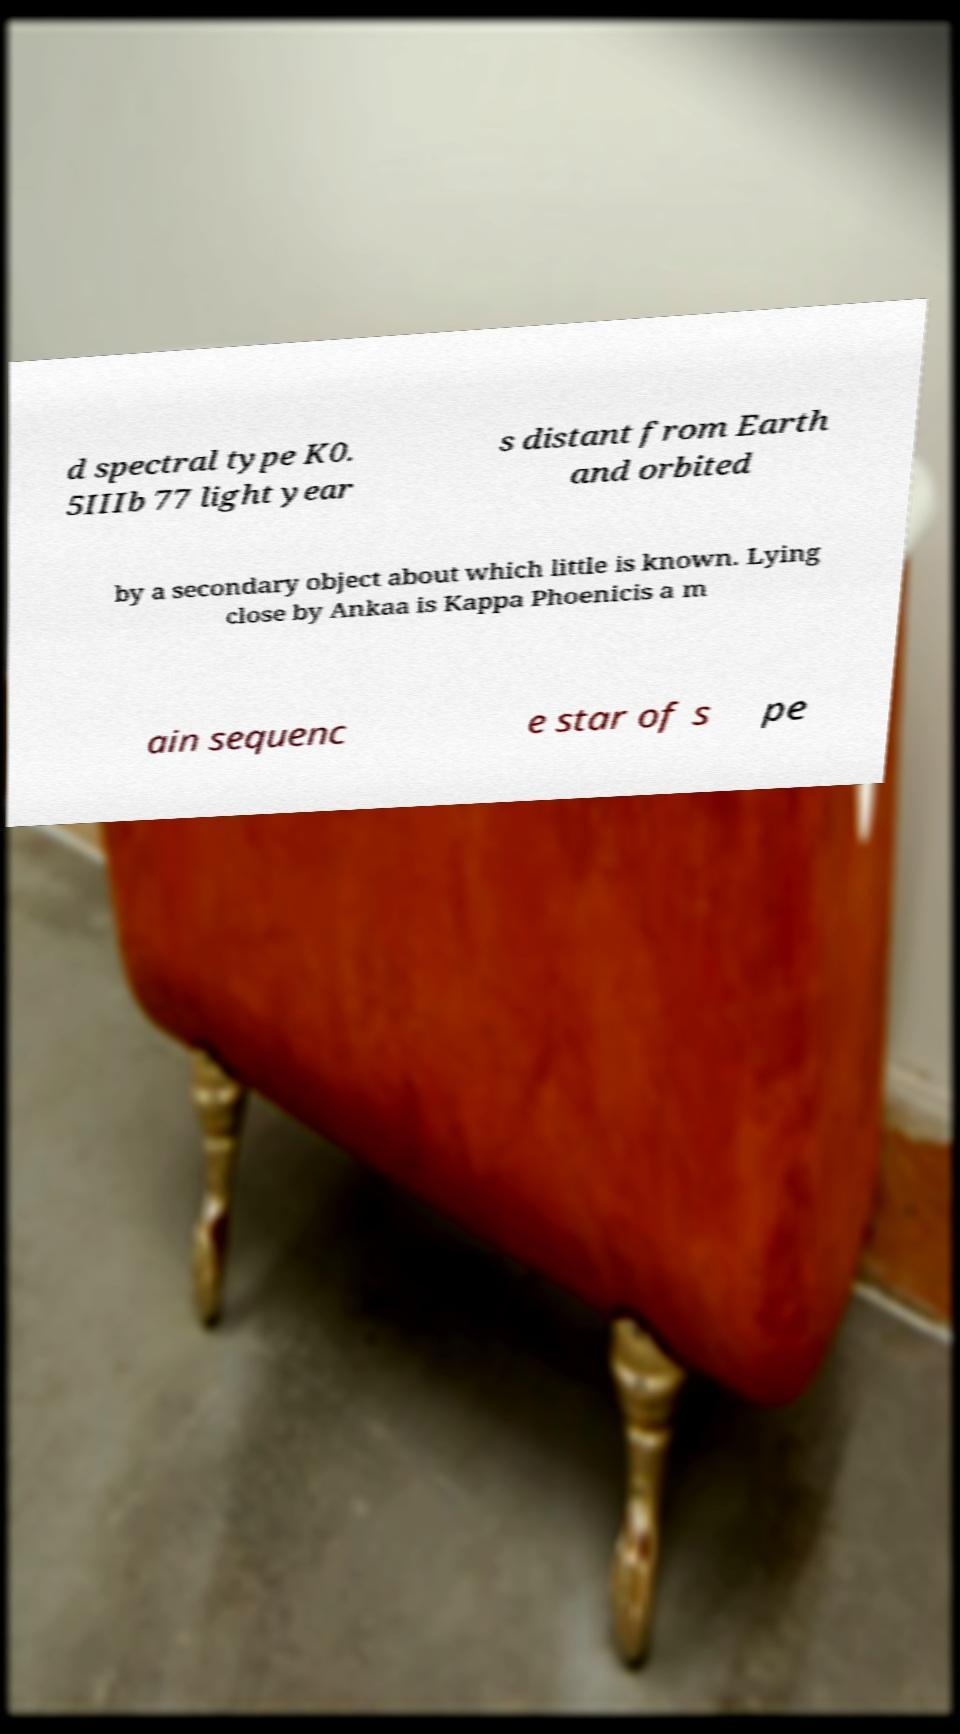Could you assist in decoding the text presented in this image and type it out clearly? d spectral type K0. 5IIIb 77 light year s distant from Earth and orbited by a secondary object about which little is known. Lying close by Ankaa is Kappa Phoenicis a m ain sequenc e star of s pe 